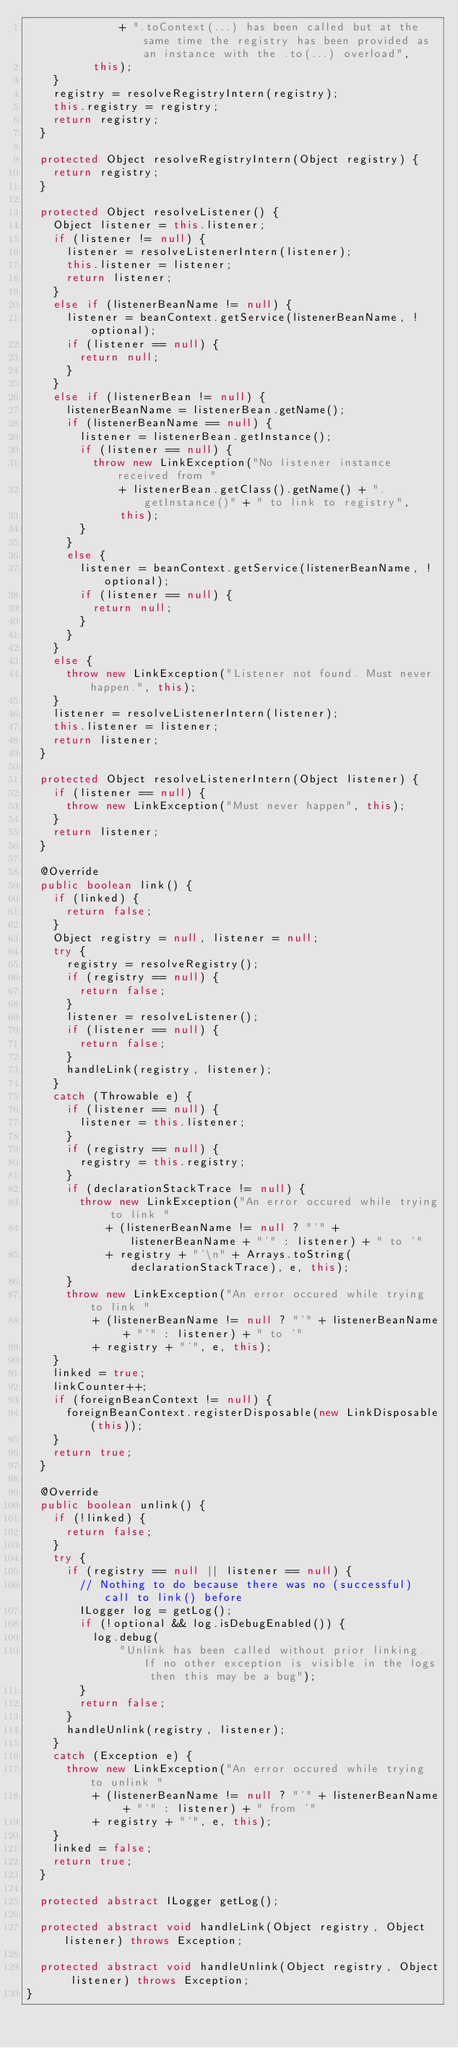Convert code to text. <code><loc_0><loc_0><loc_500><loc_500><_Java_>							+ ".toContext(...) has been called but at the same time the registry has been provided as an instance with the .to(...) overload",
					this);
		}
		registry = resolveRegistryIntern(registry);
		this.registry = registry;
		return registry;
	}

	protected Object resolveRegistryIntern(Object registry) {
		return registry;
	}

	protected Object resolveListener() {
		Object listener = this.listener;
		if (listener != null) {
			listener = resolveListenerIntern(listener);
			this.listener = listener;
			return listener;
		}
		else if (listenerBeanName != null) {
			listener = beanContext.getService(listenerBeanName, !optional);
			if (listener == null) {
				return null;
			}
		}
		else if (listenerBean != null) {
			listenerBeanName = listenerBean.getName();
			if (listenerBeanName == null) {
				listener = listenerBean.getInstance();
				if (listener == null) {
					throw new LinkException("No listener instance received from "
							+ listenerBean.getClass().getName() + ".getInstance()" + " to link to registry",
							this);
				}
			}
			else {
				listener = beanContext.getService(listenerBeanName, !optional);
				if (listener == null) {
					return null;
				}
			}
		}
		else {
			throw new LinkException("Listener not found. Must never happen.", this);
		}
		listener = resolveListenerIntern(listener);
		this.listener = listener;
		return listener;
	}

	protected Object resolveListenerIntern(Object listener) {
		if (listener == null) {
			throw new LinkException("Must never happen", this);
		}
		return listener;
	}

	@Override
	public boolean link() {
		if (linked) {
			return false;
		}
		Object registry = null, listener = null;
		try {
			registry = resolveRegistry();
			if (registry == null) {
				return false;
			}
			listener = resolveListener();
			if (listener == null) {
				return false;
			}
			handleLink(registry, listener);
		}
		catch (Throwable e) {
			if (listener == null) {
				listener = this.listener;
			}
			if (registry == null) {
				registry = this.registry;
			}
			if (declarationStackTrace != null) {
				throw new LinkException("An error occured while trying to link "
						+ (listenerBeanName != null ? "'" + listenerBeanName + "'" : listener) + " to '"
						+ registry + "'\n" + Arrays.toString(declarationStackTrace), e, this);
			}
			throw new LinkException("An error occured while trying to link "
					+ (listenerBeanName != null ? "'" + listenerBeanName + "'" : listener) + " to '"
					+ registry + "'", e, this);
		}
		linked = true;
		linkCounter++;
		if (foreignBeanContext != null) {
			foreignBeanContext.registerDisposable(new LinkDisposable(this));
		}
		return true;
	}

	@Override
	public boolean unlink() {
		if (!linked) {
			return false;
		}
		try {
			if (registry == null || listener == null) {
				// Nothing to do because there was no (successful) call to link() before
				ILogger log = getLog();
				if (!optional && log.isDebugEnabled()) {
					log.debug(
							"Unlink has been called without prior linking. If no other exception is visible in the logs then this may be a bug");
				}
				return false;
			}
			handleUnlink(registry, listener);
		}
		catch (Exception e) {
			throw new LinkException("An error occured while trying to unlink "
					+ (listenerBeanName != null ? "'" + listenerBeanName + "'" : listener) + " from '"
					+ registry + "'", e, this);
		}
		linked = false;
		return true;
	}

	protected abstract ILogger getLog();

	protected abstract void handleLink(Object registry, Object listener) throws Exception;

	protected abstract void handleUnlink(Object registry, Object listener) throws Exception;
}
</code> 